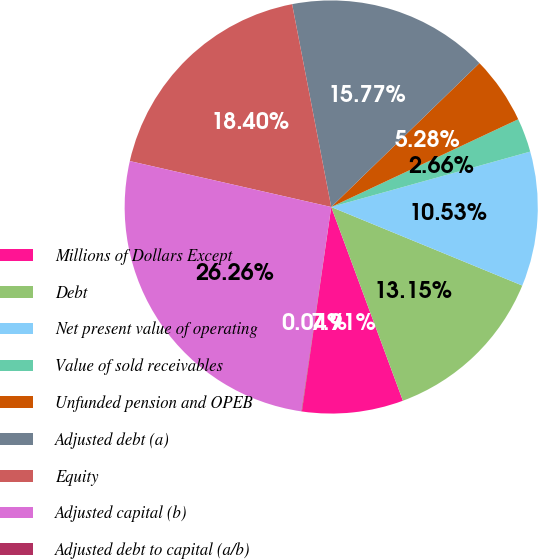Convert chart to OTSL. <chart><loc_0><loc_0><loc_500><loc_500><pie_chart><fcel>Millions of Dollars Except<fcel>Debt<fcel>Net present value of operating<fcel>Value of sold receivables<fcel>Unfunded pension and OPEB<fcel>Adjusted debt (a)<fcel>Equity<fcel>Adjusted capital (b)<fcel>Adjusted debt to capital (a/b)<nl><fcel>7.91%<fcel>13.15%<fcel>10.53%<fcel>2.66%<fcel>5.28%<fcel>15.77%<fcel>18.4%<fcel>26.26%<fcel>0.04%<nl></chart> 